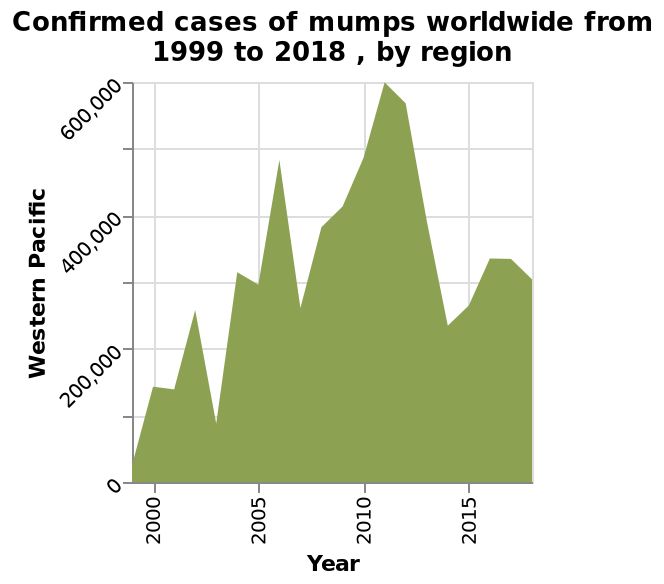<image>
What was the overall trend of confirmed cases of mumps in the Western Pacific region from 2010 to 2015?  The overall trend of confirmed cases of mumps in the Western Pacific region from 2010 to 2015 was upwards. What pattern did the confirmed cases of mumps follow in the Western Pacific region from 2010 to 2015?  The confirmed cases of mumps in the Western Pacific region from 2010 to 2015 followed a pattern of a spike in numbers followed by an extended drawn down. 